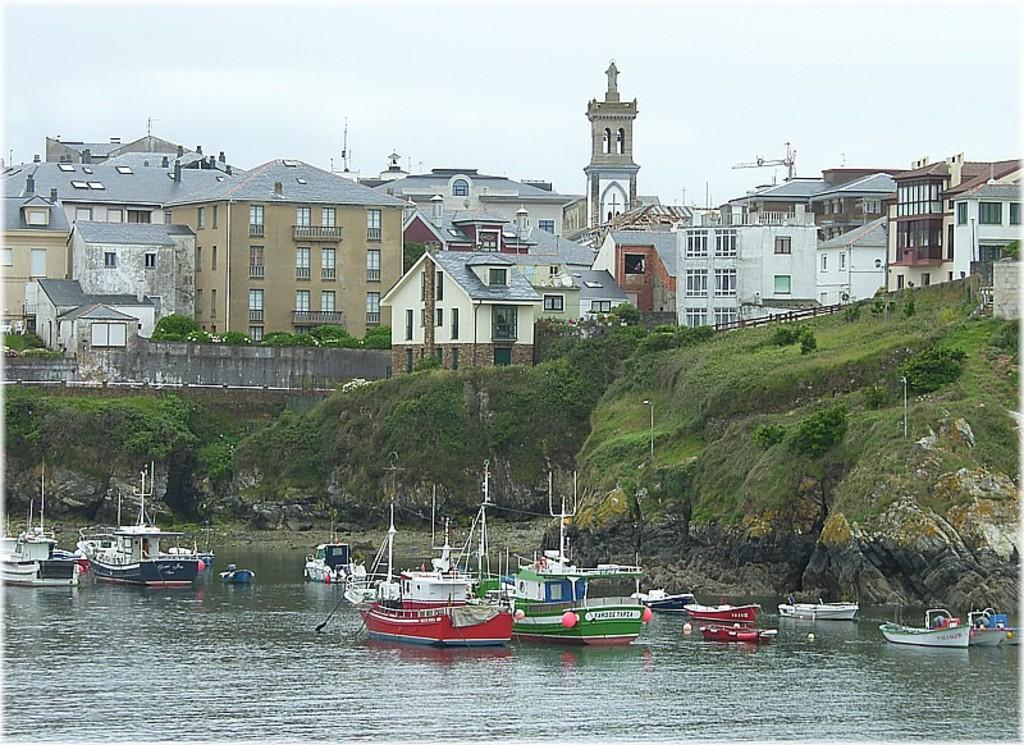What is the main subject of the image? The main subject of the image is a group of boats in a water body. What else can be seen in the water besides the boats? There are poles in the water. What type of vegetation is visible in the image? Plants, grass, and trees are visible in the image. What other objects or structures can be seen in the image? Rocks, buildings, and a fence are visible in the image. What is visible in the sky? The sky is visible in the image. How many babies are playing with a kite in the image? There are no babies or kites present in the image. What type of expansion is occurring in the image? There is no expansion occurring in the image; it is a static scene featuring boats, water, and other objects. 